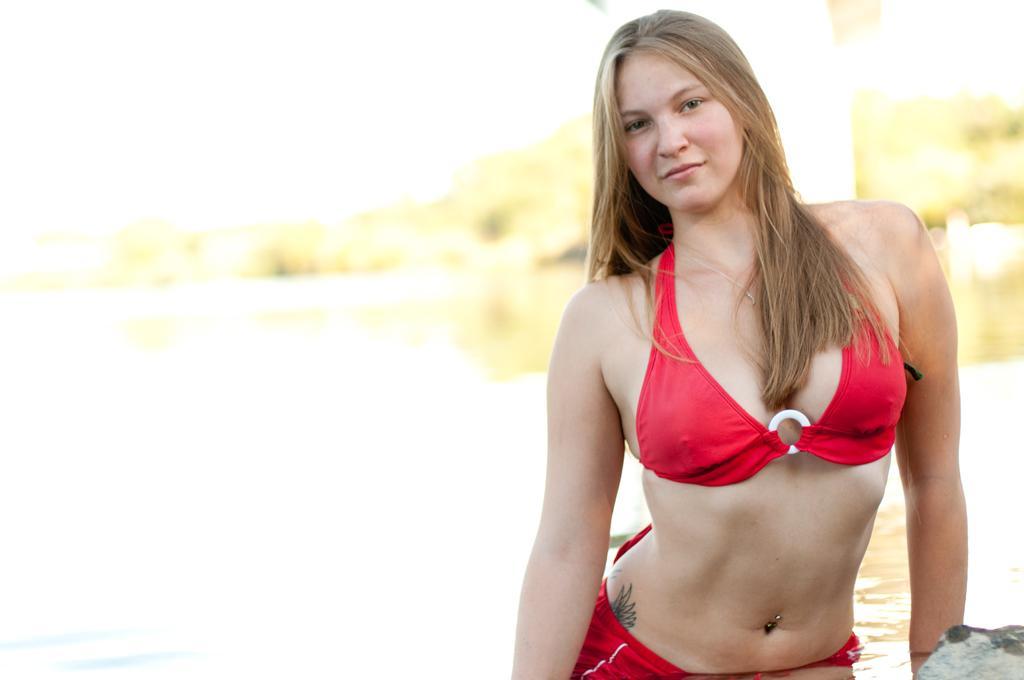In one or two sentences, can you explain what this image depicts? In the foreground I can see a woman. In the background I can see water, trees and the sky. This image is taken may be near the lake. 